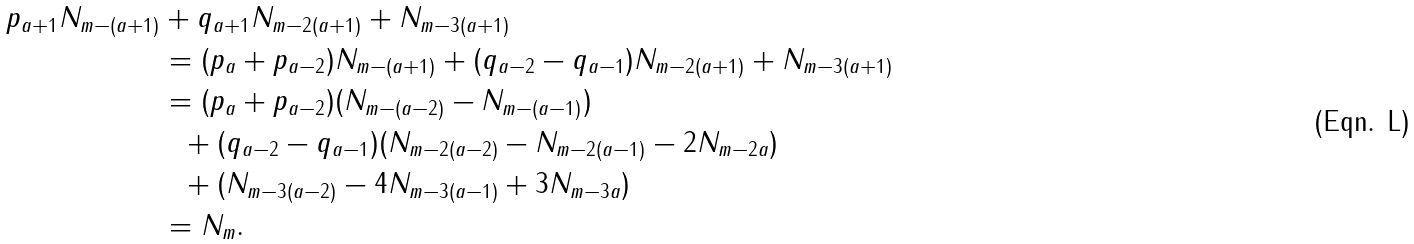Convert formula to latex. <formula><loc_0><loc_0><loc_500><loc_500>p _ { a + 1 } N _ { m - ( a + 1 ) } & + q _ { a + 1 } N _ { m - 2 ( a + 1 ) } + N _ { m - 3 ( a + 1 ) } \\ & = ( p _ { a } + p _ { a - 2 } ) N _ { m - ( a + 1 ) } + ( q _ { a - 2 } - q _ { a - 1 } ) N _ { m - 2 ( a + 1 ) } + N _ { m - 3 ( a + 1 ) } \\ & = ( p _ { a } + p _ { a - 2 } ) ( N _ { m - ( a - 2 ) } - N _ { m - ( a - 1 ) } ) \\ & \ \ + ( q _ { a - 2 } - q _ { a - 1 } ) ( N _ { m - 2 ( a - 2 ) } - N _ { m - 2 ( a - 1 ) } - 2 N _ { m - 2 a } ) \\ & \ \ + ( N _ { m - 3 ( a - 2 ) } - 4 N _ { m - 3 ( a - 1 ) } + 3 N _ { m - 3 a } ) \\ & = N _ { m } .</formula> 